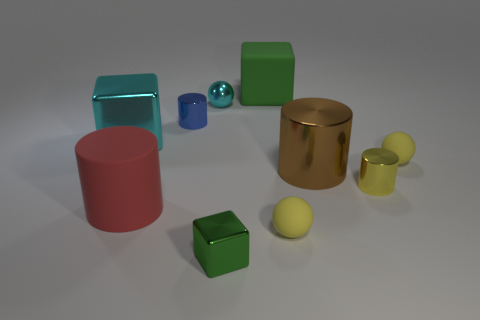Are there the same number of yellow spheres in front of the big red thing and tiny green shiny blocks?
Offer a terse response. Yes. How many big metal cubes are there?
Ensure brevity in your answer.  1. There is a matte object that is both behind the big red cylinder and in front of the blue metal cylinder; what is its shape?
Make the answer very short. Sphere. There is a large cylinder that is on the right side of the tiny block; is its color the same as the metallic cylinder in front of the big brown object?
Provide a short and direct response. No. The other cube that is the same color as the rubber block is what size?
Your answer should be very brief. Small. Is there a small purple sphere that has the same material as the small yellow cylinder?
Provide a succinct answer. No. Are there an equal number of small metal spheres that are on the right side of the green rubber object and tiny cylinders on the right side of the big brown shiny cylinder?
Make the answer very short. No. There is a cyan metal thing that is left of the tiny cyan shiny object; what size is it?
Make the answer very short. Large. There is a small cylinder in front of the small rubber ball behind the yellow metallic thing; what is its material?
Ensure brevity in your answer.  Metal. There is a green matte block that is left of the small cylinder right of the tiny cyan sphere; how many small green shiny cubes are left of it?
Ensure brevity in your answer.  1. 